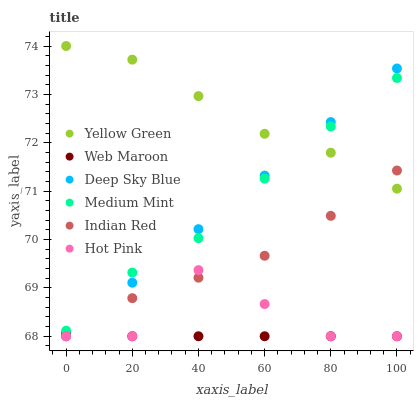Does Web Maroon have the minimum area under the curve?
Answer yes or no. Yes. Does Yellow Green have the maximum area under the curve?
Answer yes or no. Yes. Does Hot Pink have the minimum area under the curve?
Answer yes or no. No. Does Hot Pink have the maximum area under the curve?
Answer yes or no. No. Is Deep Sky Blue the smoothest?
Answer yes or no. Yes. Is Hot Pink the roughest?
Answer yes or no. Yes. Is Yellow Green the smoothest?
Answer yes or no. No. Is Yellow Green the roughest?
Answer yes or no. No. Does Hot Pink have the lowest value?
Answer yes or no. Yes. Does Yellow Green have the lowest value?
Answer yes or no. No. Does Yellow Green have the highest value?
Answer yes or no. Yes. Does Hot Pink have the highest value?
Answer yes or no. No. Is Hot Pink less than Medium Mint?
Answer yes or no. Yes. Is Medium Mint greater than Indian Red?
Answer yes or no. Yes. Does Hot Pink intersect Web Maroon?
Answer yes or no. Yes. Is Hot Pink less than Web Maroon?
Answer yes or no. No. Is Hot Pink greater than Web Maroon?
Answer yes or no. No. Does Hot Pink intersect Medium Mint?
Answer yes or no. No. 